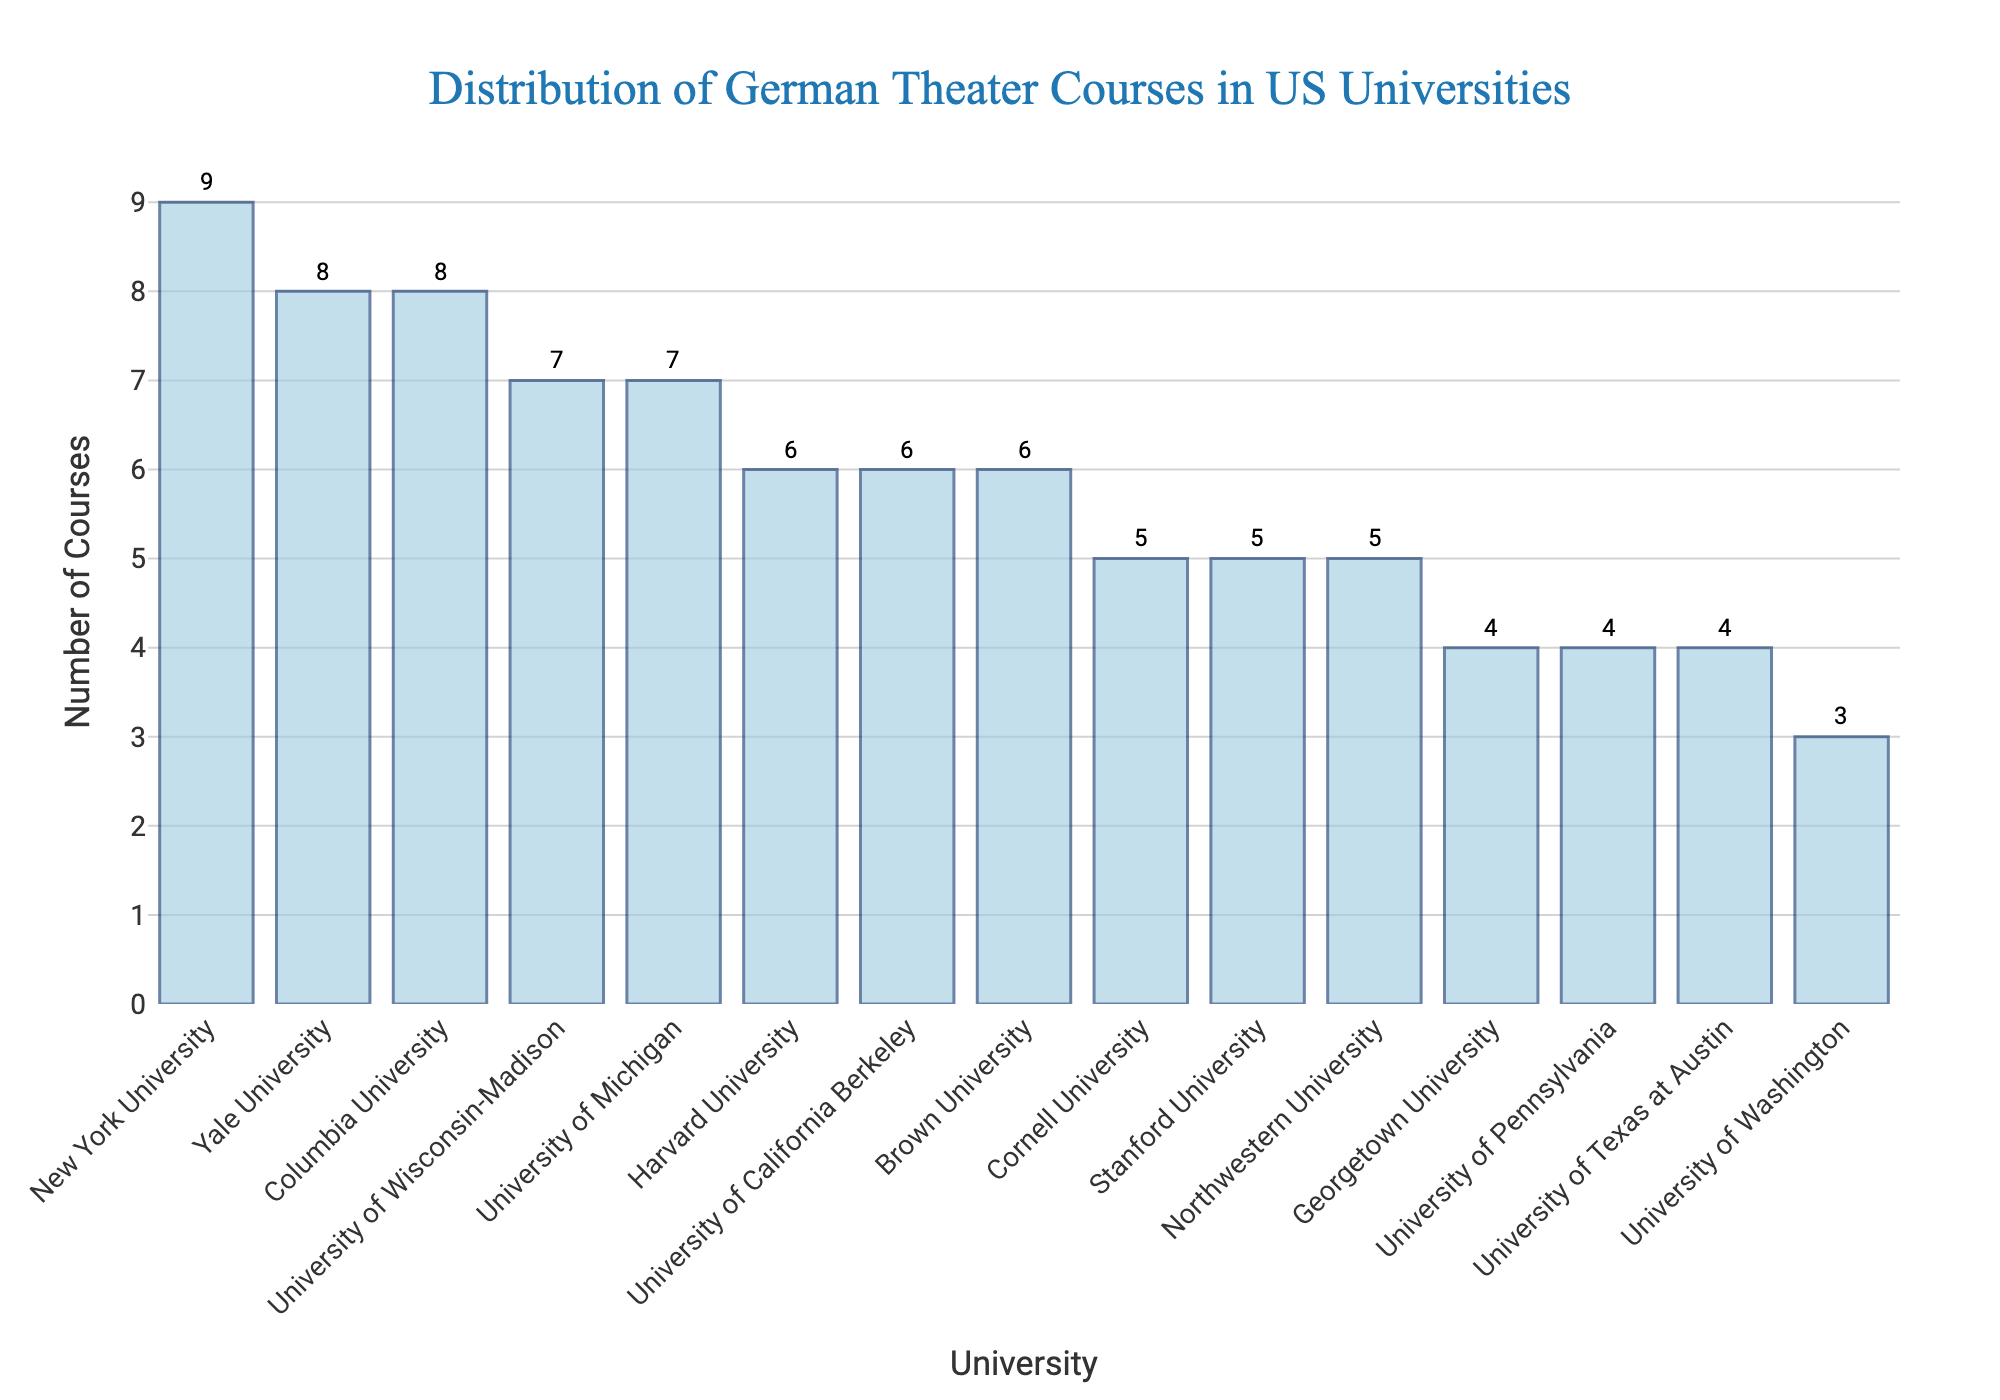Which university offers the highest number of German theater courses? From the bar heights, New York University has the highest bar, indicating it offers the most courses.
Answer: New York University Which universities offer the same number of German theater courses? By examining the bars of equal height, Stanford University, Cornell University, and Northwestern University each offer 5 courses. Similarly, University of Pennsylvania, Georgetown University, and University of Texas at Austin each offer 4 courses.
Answer: Stanford University, Cornell University, Northwestern University; University of Pennsylvania, Georgetown University, University of Texas at Austin How many universities offer more than 6 German theater courses? Count the bars that exceed the height corresponding to 6 courses. These are New York University (9), Yale University (8), Columbia University (8), University of Wisconsin-Madison (7), and University of Michigan (7).
Answer: 5 What is the median number of German theater courses among these universities? Arrange the number of courses in ascending order (3, 4, 4, 4, 5, 5, 5, 6, 6, 6, 7, 7, 8, 8, 9). The median is the middle value in this ordered list, which is 6.
Answer: 6 Which university offers the fewest number of German theater courses? The shortest bar on the chart belongs to the University of Washington, indicating it offers the fewest courses.
Answer: University of Washington What is the total number of German theater courses offered by the universities in the figure? Sum all the values: 8 (Yale) + 6 (Harvard) + 7 (Wisconsin-Madison) + 5 (Cornell) + 4 (Georgetown) + 9 (NYU) + 6 (UC Berkeley) + 5 (Stanford) + 7 (Michigan) + 8 (Columbia) + 4 (Pennsylvania) + 6 (Brown) + 5 (Northwestern) + 4 (Texas at Austin) + 3 (Washington) = 87.
Answer: 87 Compare the number of German theater courses at Columbia University and Harvard University. Columbia University offers 8 courses while Harvard University offers 6. Therefore, Columbia offers 2 more courses than Harvard.
Answer: Columbia University offers 2 more courses Which universities offer more courses than University of California Berkeley? UC Berkeley offers 6 courses, so identify universities with more than 6: New York University (9), Yale University (8), Columbia University (8), University of Wisconsin-Madison (7), University of Michigan (7).
Answer: New York University, Yale University, Columbia University, University of Wisconsin-Madison, University of Michigan How many universities offer exactly 6 German theater courses? Count the bars at the height for 6 courses: Harvard University, University of California Berkeley, Brown University.
Answer: 3 What is the average number of German theater courses offered by the top three universities? Top three universities are NYU (9), Yale (8), Columbia (8). Sum these values (9 + 8 + 8 = 25) and divide by 3 to get the average: 25 / 3 ≈ 8.33.
Answer: 8.33 